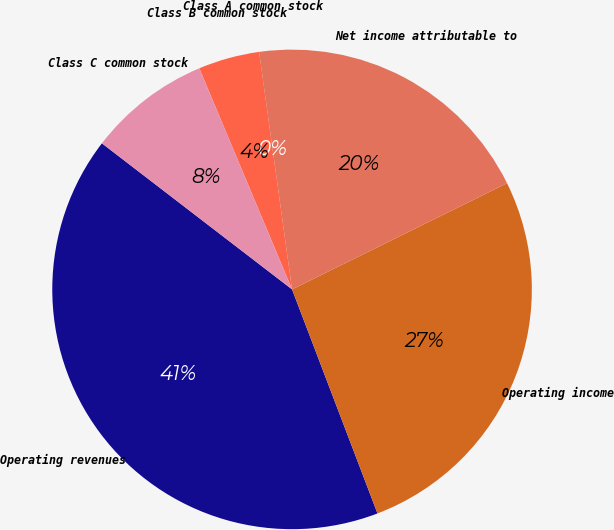Convert chart to OTSL. <chart><loc_0><loc_0><loc_500><loc_500><pie_chart><fcel>Operating revenues<fcel>Operating income<fcel>Net income attributable to<fcel>Class A common stock<fcel>Class B common stock<fcel>Class C common stock<nl><fcel>41.22%<fcel>26.5%<fcel>19.88%<fcel>0.01%<fcel>4.13%<fcel>8.25%<nl></chart> 